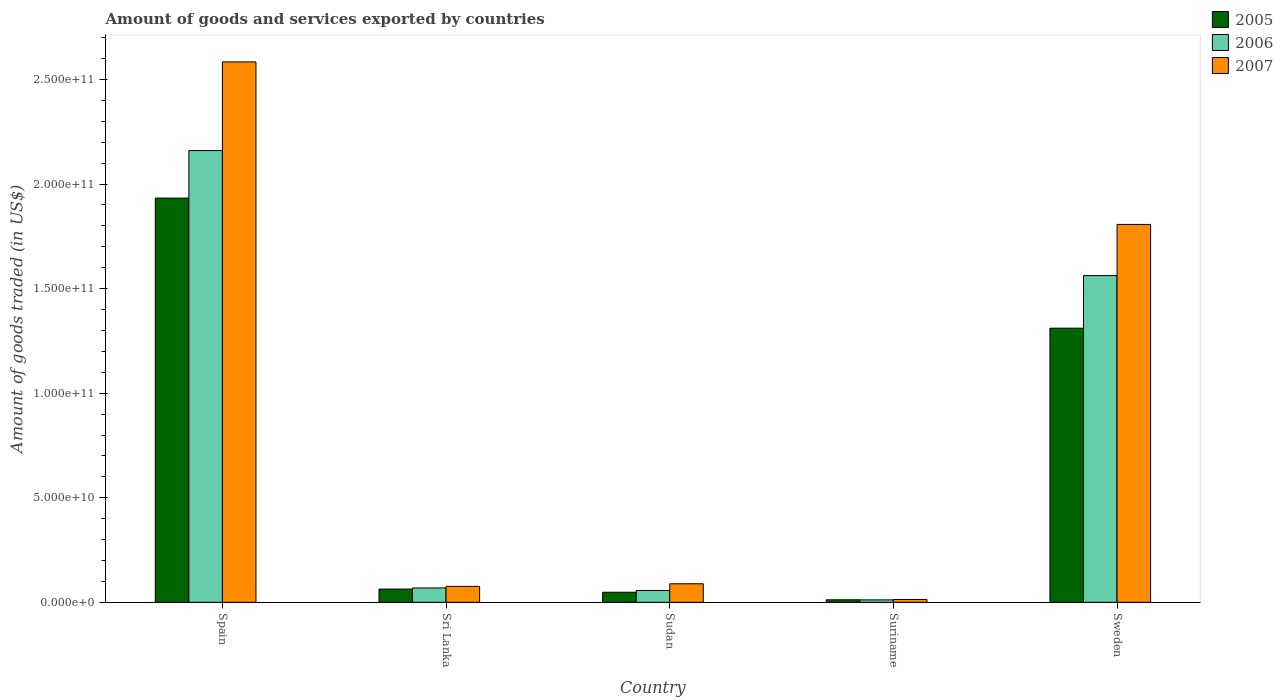How many different coloured bars are there?
Offer a terse response. 3. How many groups of bars are there?
Provide a short and direct response. 5. Are the number of bars on each tick of the X-axis equal?
Offer a terse response. Yes. How many bars are there on the 5th tick from the right?
Give a very brief answer. 3. What is the label of the 3rd group of bars from the left?
Give a very brief answer. Sudan. In how many cases, is the number of bars for a given country not equal to the number of legend labels?
Ensure brevity in your answer.  0. What is the total amount of goods and services exported in 2007 in Sweden?
Make the answer very short. 1.81e+11. Across all countries, what is the maximum total amount of goods and services exported in 2005?
Your answer should be compact. 1.93e+11. Across all countries, what is the minimum total amount of goods and services exported in 2005?
Your response must be concise. 1.21e+09. In which country was the total amount of goods and services exported in 2007 maximum?
Your answer should be compact. Spain. In which country was the total amount of goods and services exported in 2005 minimum?
Your response must be concise. Suriname. What is the total total amount of goods and services exported in 2007 in the graph?
Your response must be concise. 4.57e+11. What is the difference between the total amount of goods and services exported in 2006 in Sudan and that in Suriname?
Your answer should be compact. 4.48e+09. What is the difference between the total amount of goods and services exported in 2006 in Spain and the total amount of goods and services exported in 2007 in Sudan?
Offer a terse response. 2.07e+11. What is the average total amount of goods and services exported in 2006 per country?
Offer a terse response. 7.72e+1. What is the difference between the total amount of goods and services exported of/in 2006 and total amount of goods and services exported of/in 2005 in Sweden?
Make the answer very short. 2.51e+1. In how many countries, is the total amount of goods and services exported in 2007 greater than 110000000000 US$?
Keep it short and to the point. 2. What is the ratio of the total amount of goods and services exported in 2007 in Sudan to that in Suriname?
Offer a very short reply. 6.53. What is the difference between the highest and the second highest total amount of goods and services exported in 2006?
Your answer should be very brief. 2.09e+11. What is the difference between the highest and the lowest total amount of goods and services exported in 2007?
Keep it short and to the point. 2.57e+11. What does the 3rd bar from the right in Suriname represents?
Offer a very short reply. 2005. How many bars are there?
Ensure brevity in your answer.  15. Are all the bars in the graph horizontal?
Keep it short and to the point. No. How many countries are there in the graph?
Ensure brevity in your answer.  5. What is the difference between two consecutive major ticks on the Y-axis?
Offer a terse response. 5.00e+1. Does the graph contain any zero values?
Make the answer very short. No. How many legend labels are there?
Provide a succinct answer. 3. How are the legend labels stacked?
Your answer should be very brief. Vertical. What is the title of the graph?
Offer a terse response. Amount of goods and services exported by countries. What is the label or title of the X-axis?
Offer a very short reply. Country. What is the label or title of the Y-axis?
Provide a succinct answer. Amount of goods traded (in US$). What is the Amount of goods traded (in US$) of 2005 in Spain?
Provide a succinct answer. 1.93e+11. What is the Amount of goods traded (in US$) in 2006 in Spain?
Ensure brevity in your answer.  2.16e+11. What is the Amount of goods traded (in US$) in 2007 in Spain?
Your answer should be very brief. 2.58e+11. What is the Amount of goods traded (in US$) in 2005 in Sri Lanka?
Provide a succinct answer. 6.35e+09. What is the Amount of goods traded (in US$) of 2006 in Sri Lanka?
Keep it short and to the point. 6.88e+09. What is the Amount of goods traded (in US$) in 2007 in Sri Lanka?
Your answer should be very brief. 7.64e+09. What is the Amount of goods traded (in US$) in 2005 in Sudan?
Offer a terse response. 4.82e+09. What is the Amount of goods traded (in US$) in 2006 in Sudan?
Provide a succinct answer. 5.66e+09. What is the Amount of goods traded (in US$) in 2007 in Sudan?
Offer a very short reply. 8.88e+09. What is the Amount of goods traded (in US$) in 2005 in Suriname?
Your response must be concise. 1.21e+09. What is the Amount of goods traded (in US$) of 2006 in Suriname?
Offer a very short reply. 1.17e+09. What is the Amount of goods traded (in US$) in 2007 in Suriname?
Your answer should be very brief. 1.36e+09. What is the Amount of goods traded (in US$) of 2005 in Sweden?
Provide a succinct answer. 1.31e+11. What is the Amount of goods traded (in US$) in 2006 in Sweden?
Your answer should be compact. 1.56e+11. What is the Amount of goods traded (in US$) of 2007 in Sweden?
Provide a short and direct response. 1.81e+11. Across all countries, what is the maximum Amount of goods traded (in US$) of 2005?
Your response must be concise. 1.93e+11. Across all countries, what is the maximum Amount of goods traded (in US$) in 2006?
Keep it short and to the point. 2.16e+11. Across all countries, what is the maximum Amount of goods traded (in US$) of 2007?
Give a very brief answer. 2.58e+11. Across all countries, what is the minimum Amount of goods traded (in US$) in 2005?
Your response must be concise. 1.21e+09. Across all countries, what is the minimum Amount of goods traded (in US$) in 2006?
Offer a terse response. 1.17e+09. Across all countries, what is the minimum Amount of goods traded (in US$) in 2007?
Your answer should be very brief. 1.36e+09. What is the total Amount of goods traded (in US$) of 2005 in the graph?
Offer a terse response. 3.37e+11. What is the total Amount of goods traded (in US$) of 2006 in the graph?
Your response must be concise. 3.86e+11. What is the total Amount of goods traded (in US$) of 2007 in the graph?
Your response must be concise. 4.57e+11. What is the difference between the Amount of goods traded (in US$) in 2005 in Spain and that in Sri Lanka?
Provide a succinct answer. 1.87e+11. What is the difference between the Amount of goods traded (in US$) in 2006 in Spain and that in Sri Lanka?
Your answer should be compact. 2.09e+11. What is the difference between the Amount of goods traded (in US$) in 2007 in Spain and that in Sri Lanka?
Make the answer very short. 2.51e+11. What is the difference between the Amount of goods traded (in US$) in 2005 in Spain and that in Sudan?
Ensure brevity in your answer.  1.88e+11. What is the difference between the Amount of goods traded (in US$) in 2006 in Spain and that in Sudan?
Ensure brevity in your answer.  2.10e+11. What is the difference between the Amount of goods traded (in US$) in 2007 in Spain and that in Sudan?
Keep it short and to the point. 2.50e+11. What is the difference between the Amount of goods traded (in US$) in 2005 in Spain and that in Suriname?
Keep it short and to the point. 1.92e+11. What is the difference between the Amount of goods traded (in US$) in 2006 in Spain and that in Suriname?
Provide a short and direct response. 2.15e+11. What is the difference between the Amount of goods traded (in US$) of 2007 in Spain and that in Suriname?
Offer a very short reply. 2.57e+11. What is the difference between the Amount of goods traded (in US$) in 2005 in Spain and that in Sweden?
Provide a short and direct response. 6.22e+1. What is the difference between the Amount of goods traded (in US$) of 2006 in Spain and that in Sweden?
Keep it short and to the point. 5.98e+1. What is the difference between the Amount of goods traded (in US$) of 2007 in Spain and that in Sweden?
Offer a very short reply. 7.77e+1. What is the difference between the Amount of goods traded (in US$) of 2005 in Sri Lanka and that in Sudan?
Keep it short and to the point. 1.52e+09. What is the difference between the Amount of goods traded (in US$) in 2006 in Sri Lanka and that in Sudan?
Make the answer very short. 1.23e+09. What is the difference between the Amount of goods traded (in US$) in 2007 in Sri Lanka and that in Sudan?
Keep it short and to the point. -1.24e+09. What is the difference between the Amount of goods traded (in US$) of 2005 in Sri Lanka and that in Suriname?
Your response must be concise. 5.14e+09. What is the difference between the Amount of goods traded (in US$) of 2006 in Sri Lanka and that in Suriname?
Provide a short and direct response. 5.71e+09. What is the difference between the Amount of goods traded (in US$) in 2007 in Sri Lanka and that in Suriname?
Provide a short and direct response. 6.28e+09. What is the difference between the Amount of goods traded (in US$) in 2005 in Sri Lanka and that in Sweden?
Your answer should be very brief. -1.25e+11. What is the difference between the Amount of goods traded (in US$) of 2006 in Sri Lanka and that in Sweden?
Offer a terse response. -1.49e+11. What is the difference between the Amount of goods traded (in US$) of 2007 in Sri Lanka and that in Sweden?
Keep it short and to the point. -1.73e+11. What is the difference between the Amount of goods traded (in US$) in 2005 in Sudan and that in Suriname?
Your answer should be compact. 3.61e+09. What is the difference between the Amount of goods traded (in US$) of 2006 in Sudan and that in Suriname?
Provide a succinct answer. 4.48e+09. What is the difference between the Amount of goods traded (in US$) in 2007 in Sudan and that in Suriname?
Make the answer very short. 7.52e+09. What is the difference between the Amount of goods traded (in US$) of 2005 in Sudan and that in Sweden?
Provide a succinct answer. -1.26e+11. What is the difference between the Amount of goods traded (in US$) in 2006 in Sudan and that in Sweden?
Provide a short and direct response. -1.51e+11. What is the difference between the Amount of goods traded (in US$) in 2007 in Sudan and that in Sweden?
Keep it short and to the point. -1.72e+11. What is the difference between the Amount of goods traded (in US$) in 2005 in Suriname and that in Sweden?
Offer a terse response. -1.30e+11. What is the difference between the Amount of goods traded (in US$) of 2006 in Suriname and that in Sweden?
Ensure brevity in your answer.  -1.55e+11. What is the difference between the Amount of goods traded (in US$) in 2007 in Suriname and that in Sweden?
Provide a succinct answer. -1.79e+11. What is the difference between the Amount of goods traded (in US$) in 2005 in Spain and the Amount of goods traded (in US$) in 2006 in Sri Lanka?
Give a very brief answer. 1.86e+11. What is the difference between the Amount of goods traded (in US$) in 2005 in Spain and the Amount of goods traded (in US$) in 2007 in Sri Lanka?
Ensure brevity in your answer.  1.86e+11. What is the difference between the Amount of goods traded (in US$) of 2006 in Spain and the Amount of goods traded (in US$) of 2007 in Sri Lanka?
Your answer should be very brief. 2.08e+11. What is the difference between the Amount of goods traded (in US$) of 2005 in Spain and the Amount of goods traded (in US$) of 2006 in Sudan?
Provide a succinct answer. 1.88e+11. What is the difference between the Amount of goods traded (in US$) in 2005 in Spain and the Amount of goods traded (in US$) in 2007 in Sudan?
Make the answer very short. 1.84e+11. What is the difference between the Amount of goods traded (in US$) of 2006 in Spain and the Amount of goods traded (in US$) of 2007 in Sudan?
Your answer should be very brief. 2.07e+11. What is the difference between the Amount of goods traded (in US$) in 2005 in Spain and the Amount of goods traded (in US$) in 2006 in Suriname?
Your response must be concise. 1.92e+11. What is the difference between the Amount of goods traded (in US$) in 2005 in Spain and the Amount of goods traded (in US$) in 2007 in Suriname?
Ensure brevity in your answer.  1.92e+11. What is the difference between the Amount of goods traded (in US$) in 2006 in Spain and the Amount of goods traded (in US$) in 2007 in Suriname?
Keep it short and to the point. 2.15e+11. What is the difference between the Amount of goods traded (in US$) in 2005 in Spain and the Amount of goods traded (in US$) in 2006 in Sweden?
Offer a very short reply. 3.71e+1. What is the difference between the Amount of goods traded (in US$) of 2005 in Spain and the Amount of goods traded (in US$) of 2007 in Sweden?
Keep it short and to the point. 1.26e+1. What is the difference between the Amount of goods traded (in US$) of 2006 in Spain and the Amount of goods traded (in US$) of 2007 in Sweden?
Make the answer very short. 3.53e+1. What is the difference between the Amount of goods traded (in US$) in 2005 in Sri Lanka and the Amount of goods traded (in US$) in 2006 in Sudan?
Give a very brief answer. 6.90e+08. What is the difference between the Amount of goods traded (in US$) of 2005 in Sri Lanka and the Amount of goods traded (in US$) of 2007 in Sudan?
Your answer should be very brief. -2.53e+09. What is the difference between the Amount of goods traded (in US$) of 2006 in Sri Lanka and the Amount of goods traded (in US$) of 2007 in Sudan?
Provide a succinct answer. -2.00e+09. What is the difference between the Amount of goods traded (in US$) of 2005 in Sri Lanka and the Amount of goods traded (in US$) of 2006 in Suriname?
Your answer should be very brief. 5.17e+09. What is the difference between the Amount of goods traded (in US$) in 2005 in Sri Lanka and the Amount of goods traded (in US$) in 2007 in Suriname?
Provide a succinct answer. 4.99e+09. What is the difference between the Amount of goods traded (in US$) in 2006 in Sri Lanka and the Amount of goods traded (in US$) in 2007 in Suriname?
Ensure brevity in your answer.  5.52e+09. What is the difference between the Amount of goods traded (in US$) of 2005 in Sri Lanka and the Amount of goods traded (in US$) of 2006 in Sweden?
Your answer should be compact. -1.50e+11. What is the difference between the Amount of goods traded (in US$) in 2005 in Sri Lanka and the Amount of goods traded (in US$) in 2007 in Sweden?
Keep it short and to the point. -1.74e+11. What is the difference between the Amount of goods traded (in US$) in 2006 in Sri Lanka and the Amount of goods traded (in US$) in 2007 in Sweden?
Provide a succinct answer. -1.74e+11. What is the difference between the Amount of goods traded (in US$) in 2005 in Sudan and the Amount of goods traded (in US$) in 2006 in Suriname?
Your answer should be compact. 3.65e+09. What is the difference between the Amount of goods traded (in US$) of 2005 in Sudan and the Amount of goods traded (in US$) of 2007 in Suriname?
Provide a short and direct response. 3.47e+09. What is the difference between the Amount of goods traded (in US$) in 2006 in Sudan and the Amount of goods traded (in US$) in 2007 in Suriname?
Give a very brief answer. 4.30e+09. What is the difference between the Amount of goods traded (in US$) of 2005 in Sudan and the Amount of goods traded (in US$) of 2006 in Sweden?
Offer a very short reply. -1.51e+11. What is the difference between the Amount of goods traded (in US$) in 2005 in Sudan and the Amount of goods traded (in US$) in 2007 in Sweden?
Provide a short and direct response. -1.76e+11. What is the difference between the Amount of goods traded (in US$) in 2006 in Sudan and the Amount of goods traded (in US$) in 2007 in Sweden?
Your response must be concise. -1.75e+11. What is the difference between the Amount of goods traded (in US$) of 2005 in Suriname and the Amount of goods traded (in US$) of 2006 in Sweden?
Ensure brevity in your answer.  -1.55e+11. What is the difference between the Amount of goods traded (in US$) in 2005 in Suriname and the Amount of goods traded (in US$) in 2007 in Sweden?
Keep it short and to the point. -1.79e+11. What is the difference between the Amount of goods traded (in US$) in 2006 in Suriname and the Amount of goods traded (in US$) in 2007 in Sweden?
Provide a succinct answer. -1.80e+11. What is the average Amount of goods traded (in US$) in 2005 per country?
Provide a succinct answer. 6.73e+1. What is the average Amount of goods traded (in US$) in 2006 per country?
Your response must be concise. 7.72e+1. What is the average Amount of goods traded (in US$) in 2007 per country?
Ensure brevity in your answer.  9.14e+1. What is the difference between the Amount of goods traded (in US$) of 2005 and Amount of goods traded (in US$) of 2006 in Spain?
Offer a very short reply. -2.27e+1. What is the difference between the Amount of goods traded (in US$) of 2005 and Amount of goods traded (in US$) of 2007 in Spain?
Keep it short and to the point. -6.51e+1. What is the difference between the Amount of goods traded (in US$) in 2006 and Amount of goods traded (in US$) in 2007 in Spain?
Your response must be concise. -4.24e+1. What is the difference between the Amount of goods traded (in US$) of 2005 and Amount of goods traded (in US$) of 2006 in Sri Lanka?
Keep it short and to the point. -5.36e+08. What is the difference between the Amount of goods traded (in US$) in 2005 and Amount of goods traded (in US$) in 2007 in Sri Lanka?
Make the answer very short. -1.29e+09. What is the difference between the Amount of goods traded (in US$) in 2006 and Amount of goods traded (in US$) in 2007 in Sri Lanka?
Make the answer very short. -7.57e+08. What is the difference between the Amount of goods traded (in US$) of 2005 and Amount of goods traded (in US$) of 2006 in Sudan?
Offer a very short reply. -8.32e+08. What is the difference between the Amount of goods traded (in US$) of 2005 and Amount of goods traded (in US$) of 2007 in Sudan?
Offer a terse response. -4.05e+09. What is the difference between the Amount of goods traded (in US$) of 2006 and Amount of goods traded (in US$) of 2007 in Sudan?
Your answer should be very brief. -3.22e+09. What is the difference between the Amount of goods traded (in US$) of 2005 and Amount of goods traded (in US$) of 2006 in Suriname?
Your response must be concise. 3.70e+07. What is the difference between the Amount of goods traded (in US$) of 2005 and Amount of goods traded (in US$) of 2007 in Suriname?
Give a very brief answer. -1.48e+08. What is the difference between the Amount of goods traded (in US$) of 2006 and Amount of goods traded (in US$) of 2007 in Suriname?
Provide a short and direct response. -1.84e+08. What is the difference between the Amount of goods traded (in US$) in 2005 and Amount of goods traded (in US$) in 2006 in Sweden?
Keep it short and to the point. -2.51e+1. What is the difference between the Amount of goods traded (in US$) in 2005 and Amount of goods traded (in US$) in 2007 in Sweden?
Your answer should be very brief. -4.96e+1. What is the difference between the Amount of goods traded (in US$) in 2006 and Amount of goods traded (in US$) in 2007 in Sweden?
Ensure brevity in your answer.  -2.45e+1. What is the ratio of the Amount of goods traded (in US$) of 2005 in Spain to that in Sri Lanka?
Your answer should be compact. 30.45. What is the ratio of the Amount of goods traded (in US$) of 2006 in Spain to that in Sri Lanka?
Your answer should be very brief. 31.39. What is the ratio of the Amount of goods traded (in US$) in 2007 in Spain to that in Sri Lanka?
Offer a very short reply. 33.82. What is the ratio of the Amount of goods traded (in US$) of 2005 in Spain to that in Sudan?
Your answer should be compact. 40.06. What is the ratio of the Amount of goods traded (in US$) of 2006 in Spain to that in Sudan?
Keep it short and to the point. 38.19. What is the ratio of the Amount of goods traded (in US$) of 2007 in Spain to that in Sudan?
Provide a succinct answer. 29.1. What is the ratio of the Amount of goods traded (in US$) in 2005 in Spain to that in Suriname?
Your answer should be compact. 159.54. What is the ratio of the Amount of goods traded (in US$) of 2006 in Spain to that in Suriname?
Keep it short and to the point. 183.92. What is the ratio of the Amount of goods traded (in US$) in 2007 in Spain to that in Suriname?
Provide a succinct answer. 190.14. What is the ratio of the Amount of goods traded (in US$) of 2005 in Spain to that in Sweden?
Provide a succinct answer. 1.47. What is the ratio of the Amount of goods traded (in US$) in 2006 in Spain to that in Sweden?
Provide a short and direct response. 1.38. What is the ratio of the Amount of goods traded (in US$) of 2007 in Spain to that in Sweden?
Offer a terse response. 1.43. What is the ratio of the Amount of goods traded (in US$) of 2005 in Sri Lanka to that in Sudan?
Your response must be concise. 1.32. What is the ratio of the Amount of goods traded (in US$) of 2006 in Sri Lanka to that in Sudan?
Offer a terse response. 1.22. What is the ratio of the Amount of goods traded (in US$) in 2007 in Sri Lanka to that in Sudan?
Offer a terse response. 0.86. What is the ratio of the Amount of goods traded (in US$) of 2005 in Sri Lanka to that in Suriname?
Offer a very short reply. 5.24. What is the ratio of the Amount of goods traded (in US$) in 2006 in Sri Lanka to that in Suriname?
Offer a very short reply. 5.86. What is the ratio of the Amount of goods traded (in US$) of 2007 in Sri Lanka to that in Suriname?
Your response must be concise. 5.62. What is the ratio of the Amount of goods traded (in US$) in 2005 in Sri Lanka to that in Sweden?
Make the answer very short. 0.05. What is the ratio of the Amount of goods traded (in US$) in 2006 in Sri Lanka to that in Sweden?
Keep it short and to the point. 0.04. What is the ratio of the Amount of goods traded (in US$) of 2007 in Sri Lanka to that in Sweden?
Provide a short and direct response. 0.04. What is the ratio of the Amount of goods traded (in US$) in 2005 in Sudan to that in Suriname?
Provide a short and direct response. 3.98. What is the ratio of the Amount of goods traded (in US$) in 2006 in Sudan to that in Suriname?
Your response must be concise. 4.82. What is the ratio of the Amount of goods traded (in US$) of 2007 in Sudan to that in Suriname?
Your answer should be compact. 6.53. What is the ratio of the Amount of goods traded (in US$) in 2005 in Sudan to that in Sweden?
Your answer should be compact. 0.04. What is the ratio of the Amount of goods traded (in US$) in 2006 in Sudan to that in Sweden?
Your answer should be very brief. 0.04. What is the ratio of the Amount of goods traded (in US$) in 2007 in Sudan to that in Sweden?
Your response must be concise. 0.05. What is the ratio of the Amount of goods traded (in US$) of 2005 in Suriname to that in Sweden?
Your response must be concise. 0.01. What is the ratio of the Amount of goods traded (in US$) of 2006 in Suriname to that in Sweden?
Offer a very short reply. 0.01. What is the ratio of the Amount of goods traded (in US$) of 2007 in Suriname to that in Sweden?
Your answer should be compact. 0.01. What is the difference between the highest and the second highest Amount of goods traded (in US$) of 2005?
Make the answer very short. 6.22e+1. What is the difference between the highest and the second highest Amount of goods traded (in US$) in 2006?
Ensure brevity in your answer.  5.98e+1. What is the difference between the highest and the second highest Amount of goods traded (in US$) in 2007?
Provide a succinct answer. 7.77e+1. What is the difference between the highest and the lowest Amount of goods traded (in US$) in 2005?
Ensure brevity in your answer.  1.92e+11. What is the difference between the highest and the lowest Amount of goods traded (in US$) in 2006?
Offer a terse response. 2.15e+11. What is the difference between the highest and the lowest Amount of goods traded (in US$) of 2007?
Your answer should be compact. 2.57e+11. 